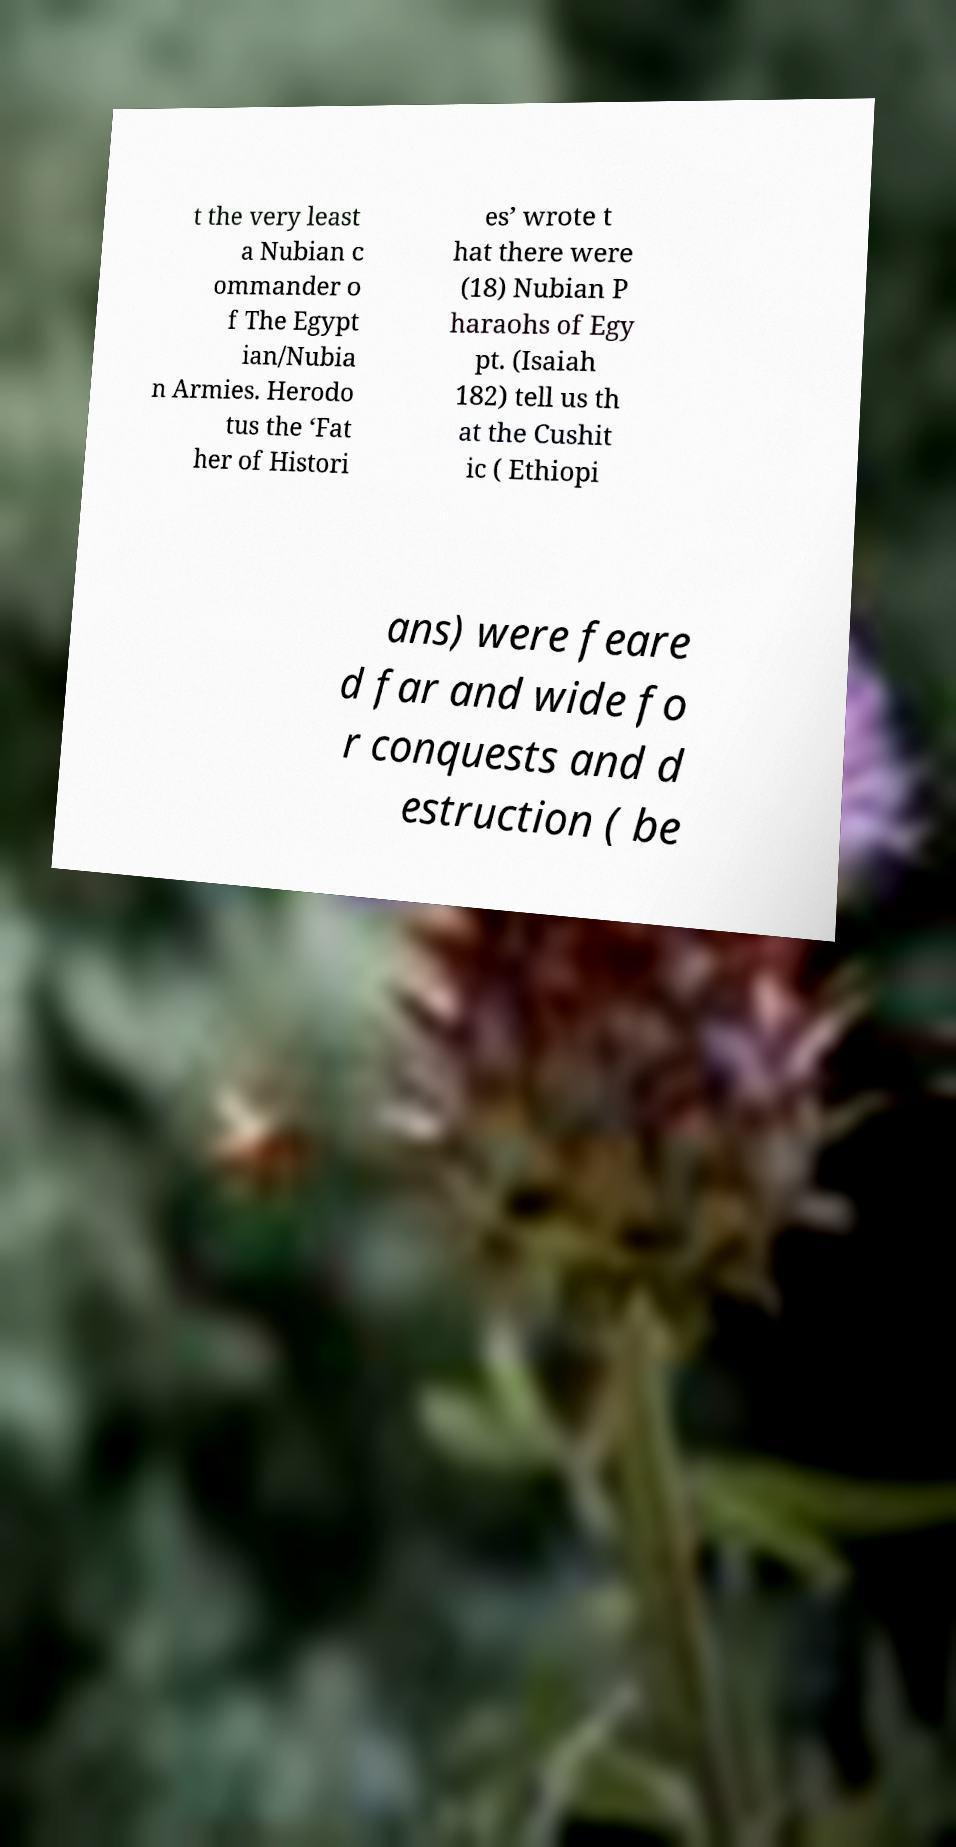Could you assist in decoding the text presented in this image and type it out clearly? t the very least a Nubian c ommander o f The Egypt ian/Nubia n Armies. Herodo tus the ‘Fat her of Histori es’ wrote t hat there were (18) Nubian P haraohs of Egy pt. (Isaiah 182) tell us th at the Cushit ic ( Ethiopi ans) were feare d far and wide fo r conquests and d estruction ( be 